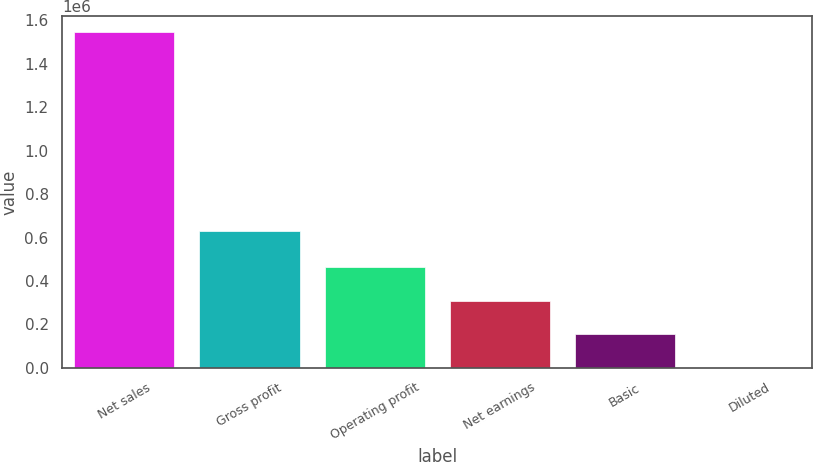Convert chart to OTSL. <chart><loc_0><loc_0><loc_500><loc_500><bar_chart><fcel>Net sales<fcel>Gross profit<fcel>Operating profit<fcel>Net earnings<fcel>Basic<fcel>Diluted<nl><fcel>1.54319e+06<fcel>631261<fcel>462958<fcel>308639<fcel>154320<fcel>0.45<nl></chart> 